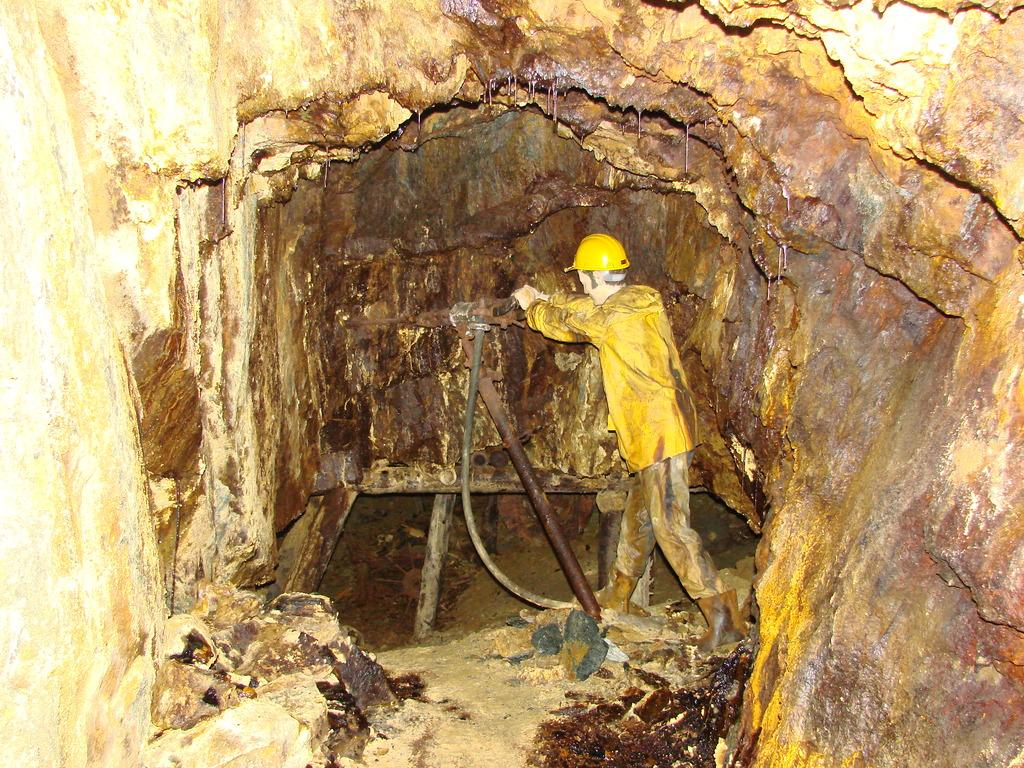Where is the person located in the image? The person is standing inside a cave in the image. What is the person holding in the image? The person is holding a machine in the image. What can be seen on the ground in the image? There are stones on the ground in the image. What type of twig is the person using to play basketball in the image? There is no twig or basketball present in the image; the person is holding a machine and standing inside a cave. 